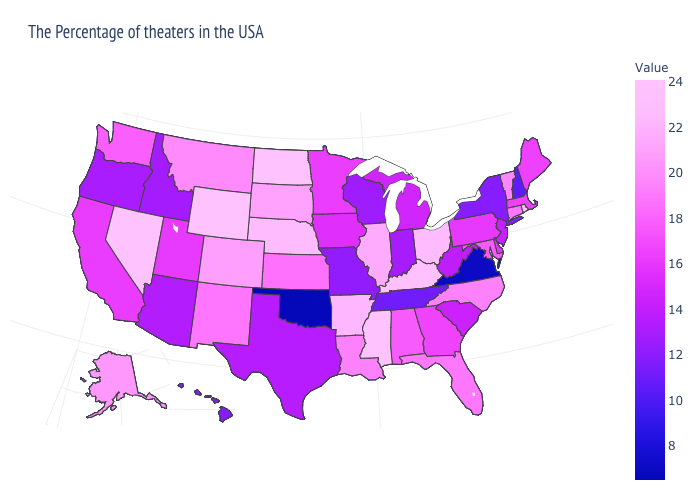Among the states that border Nevada , which have the highest value?
Answer briefly. California. Does South Carolina have a lower value than Missouri?
Keep it brief. No. Among the states that border New Hampshire , which have the highest value?
Quick response, please. Vermont. 